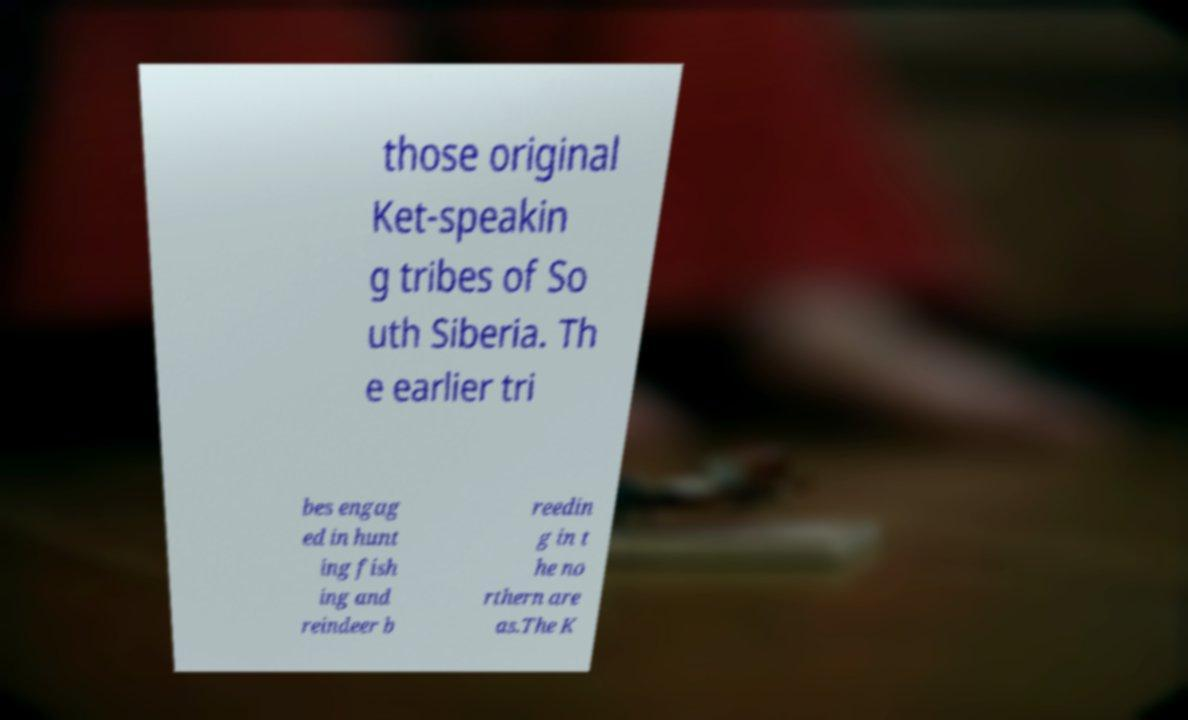Can you read and provide the text displayed in the image?This photo seems to have some interesting text. Can you extract and type it out for me? those original Ket-speakin g tribes of So uth Siberia. Th e earlier tri bes engag ed in hunt ing fish ing and reindeer b reedin g in t he no rthern are as.The K 